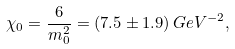Convert formula to latex. <formula><loc_0><loc_0><loc_500><loc_500>\chi _ { 0 } = \frac { 6 } { m _ { 0 } ^ { 2 } } = ( 7 . 5 \pm 1 . 9 ) \, { G e V } ^ { - 2 } ,</formula> 